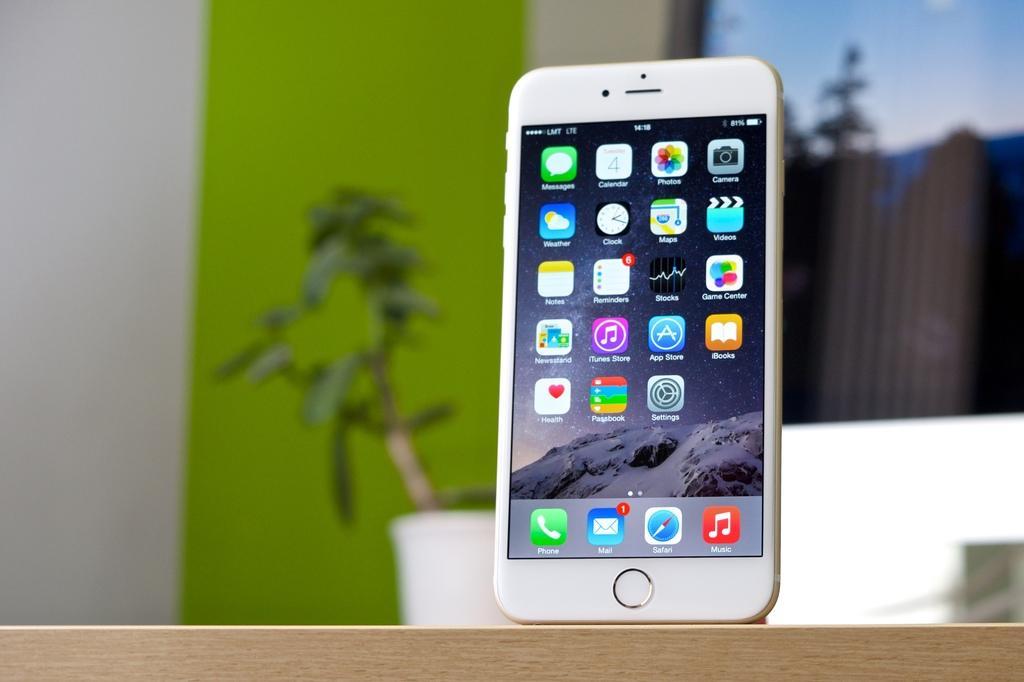Can you describe this image briefly? In this image we can see a mobile. At the bottom there is a wooden block. In the background we can see a houseplant, screen and a wall. 